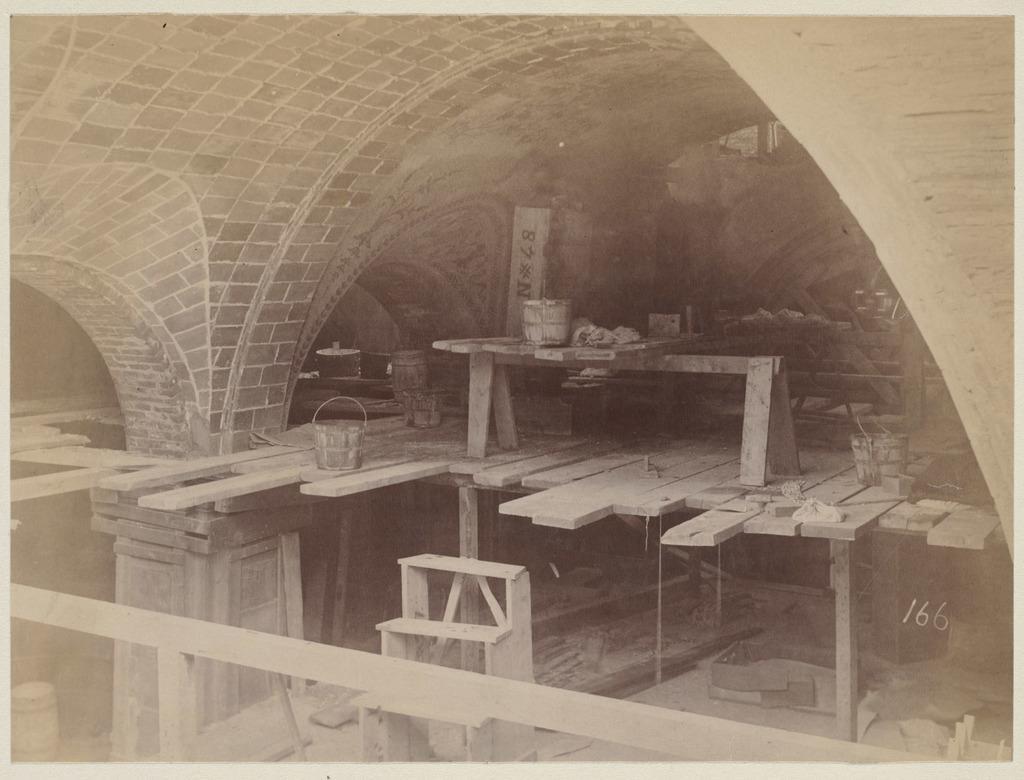Please provide a concise description of this image. In the image we can see a stone constructed building. This is a bucket and there are many wooden sheets, this is a floor and a number. 